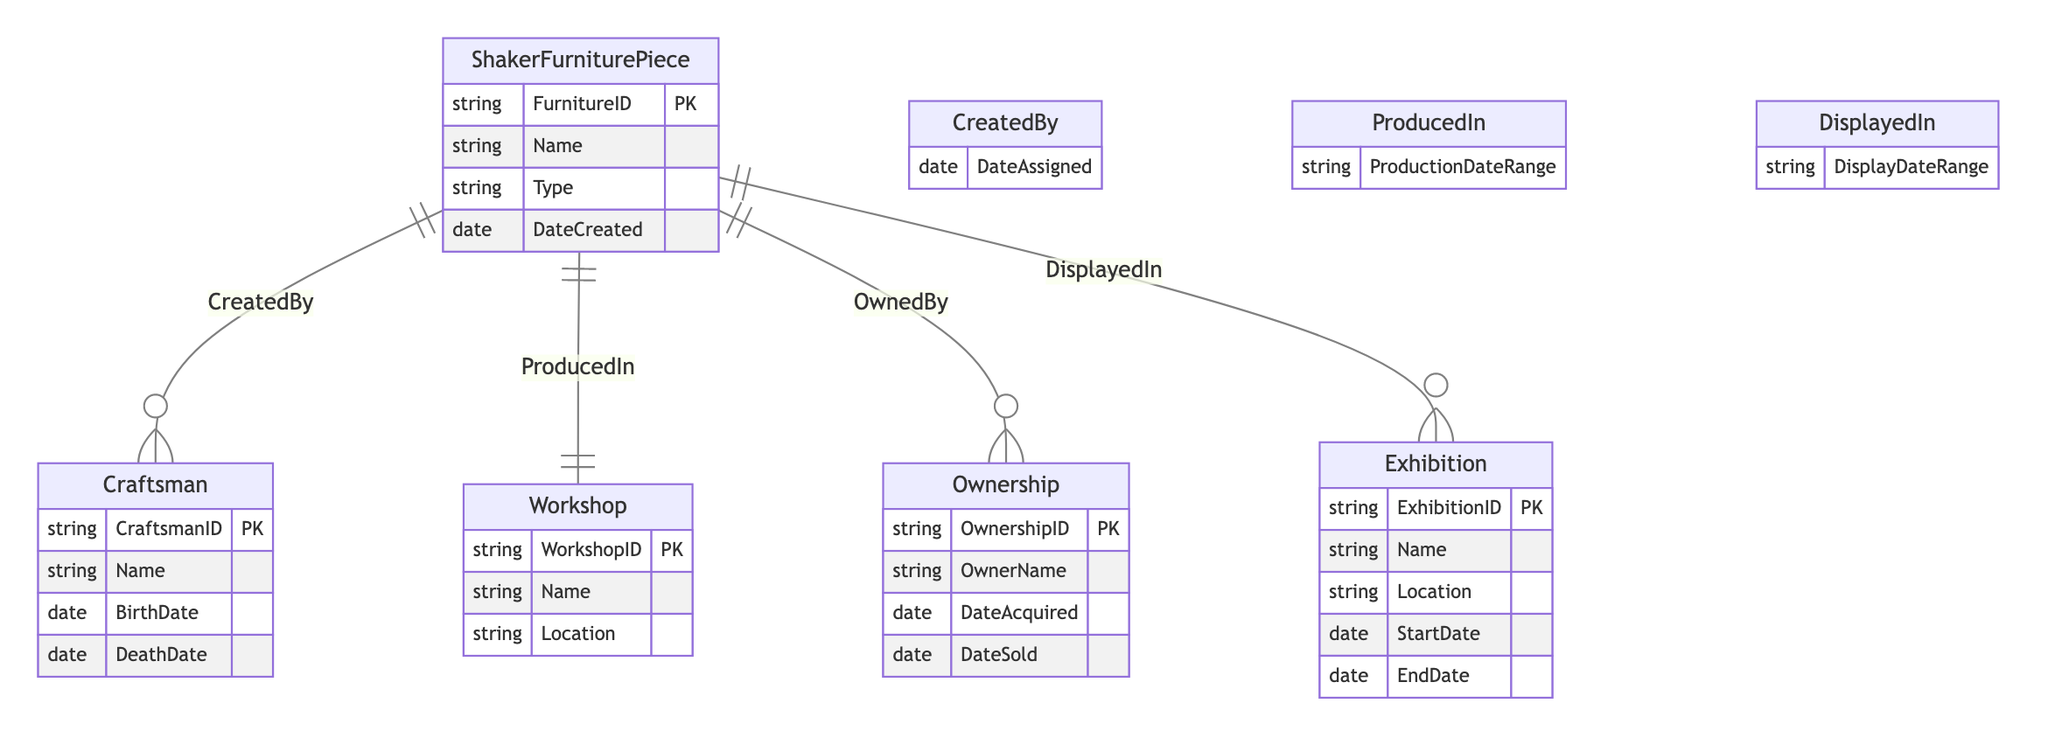What is the primary key of the ShakerFurniturePiece entity? The primary key is specified in the diagram as FurnitureID, which uniquely identifies each piece of furniture.
Answer: FurnitureID How many attributes does the Craftsman entity have? The Craftsman entity has four attributes: CraftsmanID, Name, BirthDate, and DeathDate. To count them, you simply list them: 1) CraftsmanID, 2) Name, 3) BirthDate, and 4) DeathDate.
Answer: 4 What relationship connects ShakerFurniturePiece to Craftsman? In the diagram, the relationship between ShakerFurniturePiece and Craftsman is labeled "CreatedBy." This indicates that the craftsman who created the furniture piece is linked to that piece.
Answer: CreatedBy Which entity is associated with the DisplayedIn relationship? The DisplayedIn relationship connects ShakerFurniturePiece to the Exhibition entity. This shows that a piece of furniture can be displayed in exhibitions.
Answer: Exhibition What attribute does the OwnedBy relationship lack? The OwnedBy relationship does not have any specific attributes listed. It simply connects ShakerFurniturePiece to Ownership without extra details beyond the entities involved.
Answer: None Which entity has a location attribute? The Workshop entity has a Location attribute, indicating that each workshop has a specific geographical location associated with it.
Answer: Workshop What is the type of the DateCreated attribute in the ShakerFurniturePiece entity? In the diagram, the DateCreated attribute is specified as a date type, indicating that it holds date values representing when the furniture piece was created.
Answer: date What is the relationship between ShakerFurniturePiece and Workshop? The relationship is labeled "ProducedIn," indicating that each piece of furniture is made in a specific workshop. This shows the link between the furniture and its place of production.
Answer: ProducedIn How many entities are involved in the diagram? The diagram includes five entities: ShakerFurniturePiece, Craftsman, Workshop, Ownership, and Exhibition. Counting them together gives the total number of entities.
Answer: 5 Which attribute indicates the timeline of ownership in the Ownership entity? The Ownership entity includes the DateAcquired and DateSold attributes, which together indicate the timeline of ownership for a piece of furniture.
Answer: DateAcquired, DateSold 